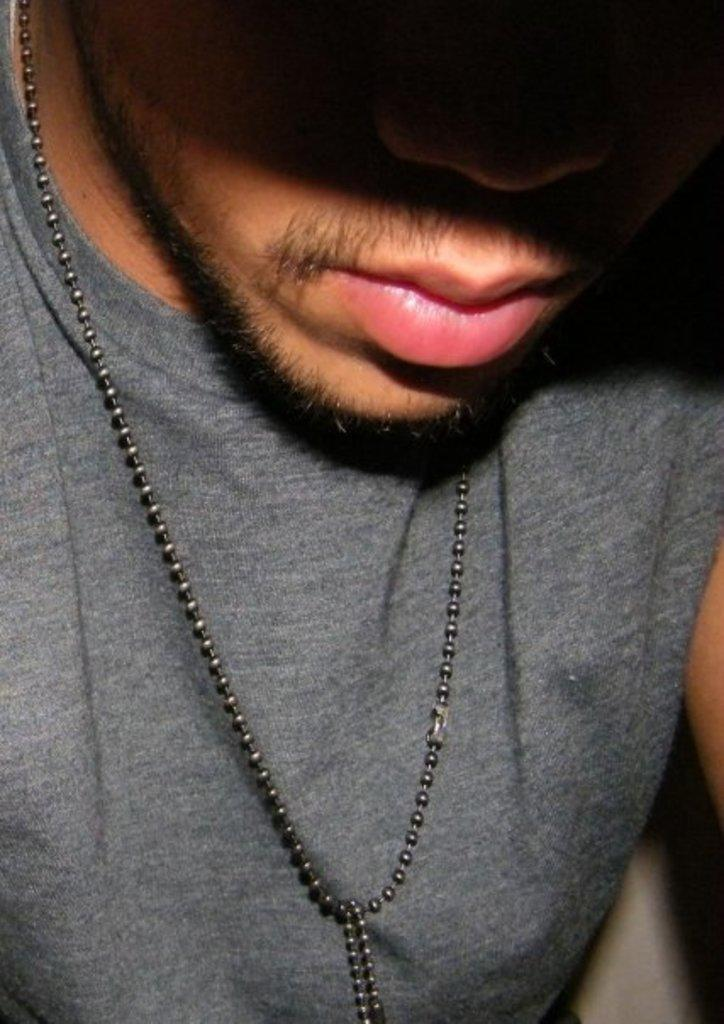Who is present in the image? There is a man in the image. What is the man wearing around his neck? The man has a chain around his neck. What type of jam is the man holding in the image? There is no jam present in the image; the man has a chain around his neck. 